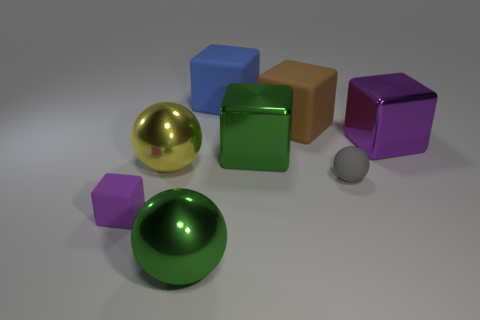Are there fewer big green shiny balls than cyan metal cubes?
Make the answer very short. No. There is a green thing behind the green ball; is it the same shape as the large yellow metallic object?
Offer a very short reply. No. Are there any cyan rubber objects?
Offer a terse response. No. The small object that is right of the purple cube on the left side of the green object to the left of the big blue object is what color?
Give a very brief answer. Gray. Is the number of big brown blocks in front of the tiny purple matte cube the same as the number of purple cubes that are in front of the big green sphere?
Your answer should be compact. Yes. What is the shape of the green object that is the same size as the green cube?
Make the answer very short. Sphere. Are there any objects that have the same color as the tiny rubber sphere?
Your response must be concise. No. What shape is the rubber thing to the right of the big brown matte thing?
Keep it short and to the point. Sphere. The small rubber cube has what color?
Offer a terse response. Purple. There is a large ball that is the same material as the yellow thing; what is its color?
Your response must be concise. Green. 